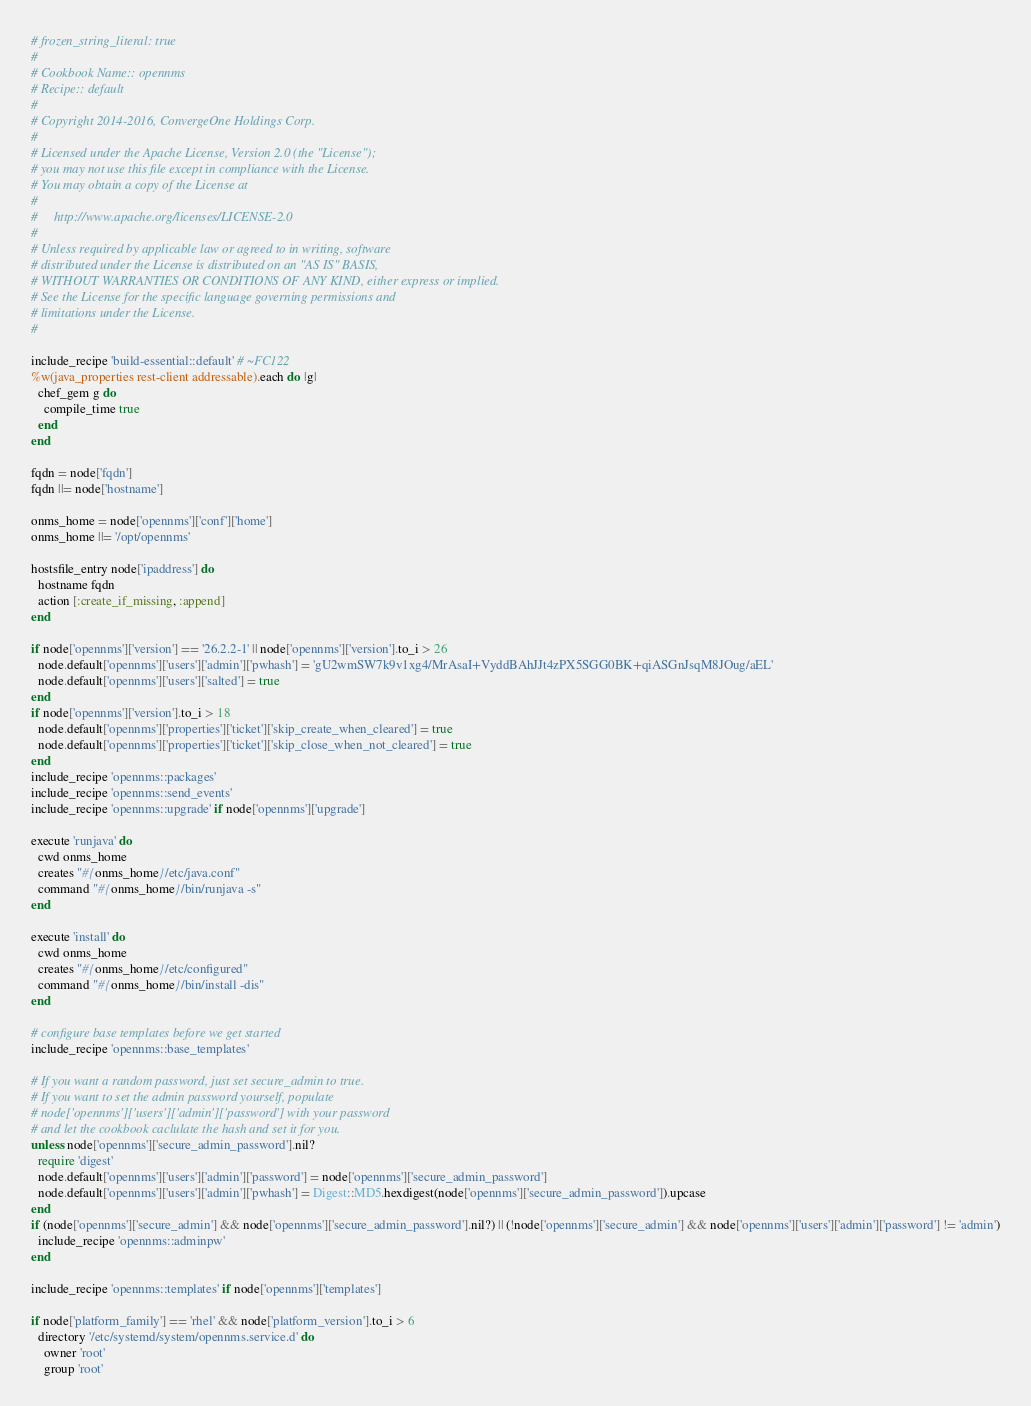<code> <loc_0><loc_0><loc_500><loc_500><_Ruby_># frozen_string_literal: true
#
# Cookbook Name:: opennms
# Recipe:: default
#
# Copyright 2014-2016, ConvergeOne Holdings Corp.
#
# Licensed under the Apache License, Version 2.0 (the "License");
# you may not use this file except in compliance with the License.
# You may obtain a copy of the License at
#
#     http://www.apache.org/licenses/LICENSE-2.0
#
# Unless required by applicable law or agreed to in writing, software
# distributed under the License is distributed on an "AS IS" BASIS,
# WITHOUT WARRANTIES OR CONDITIONS OF ANY KIND, either express or implied.
# See the License for the specific language governing permissions and
# limitations under the License.
#

include_recipe 'build-essential::default' # ~FC122
%w(java_properties rest-client addressable).each do |g|
  chef_gem g do
    compile_time true
  end
end

fqdn = node['fqdn']
fqdn ||= node['hostname']

onms_home = node['opennms']['conf']['home']
onms_home ||= '/opt/opennms'

hostsfile_entry node['ipaddress'] do
  hostname fqdn
  action [:create_if_missing, :append]
end

if node['opennms']['version'] == '26.2.2-1' || node['opennms']['version'].to_i > 26
  node.default['opennms']['users']['admin']['pwhash'] = 'gU2wmSW7k9v1xg4/MrAsaI+VyddBAhJJt4zPX5SGG0BK+qiASGnJsqM8JOug/aEL'
  node.default['opennms']['users']['salted'] = true
end
if node['opennms']['version'].to_i > 18
  node.default['opennms']['properties']['ticket']['skip_create_when_cleared'] = true
  node.default['opennms']['properties']['ticket']['skip_close_when_not_cleared'] = true
end
include_recipe 'opennms::packages'
include_recipe 'opennms::send_events'
include_recipe 'opennms::upgrade' if node['opennms']['upgrade']

execute 'runjava' do
  cwd onms_home
  creates "#{onms_home}/etc/java.conf"
  command "#{onms_home}/bin/runjava -s"
end

execute 'install' do
  cwd onms_home
  creates "#{onms_home}/etc/configured"
  command "#{onms_home}/bin/install -dis"
end

# configure base templates before we get started
include_recipe 'opennms::base_templates'

# If you want a random password, just set secure_admin to true.
# If you want to set the admin password yourself, populate
# node['opennms']['users']['admin']['password'] with your password
# and let the cookbook caclulate the hash and set it for you.
unless node['opennms']['secure_admin_password'].nil?
  require 'digest'
  node.default['opennms']['users']['admin']['password'] = node['opennms']['secure_admin_password']
  node.default['opennms']['users']['admin']['pwhash'] = Digest::MD5.hexdigest(node['opennms']['secure_admin_password']).upcase
end
if (node['opennms']['secure_admin'] && node['opennms']['secure_admin_password'].nil?) || (!node['opennms']['secure_admin'] && node['opennms']['users']['admin']['password'] != 'admin')
  include_recipe 'opennms::adminpw'
end

include_recipe 'opennms::templates' if node['opennms']['templates']

if node['platform_family'] == 'rhel' && node['platform_version'].to_i > 6
  directory '/etc/systemd/system/opennms.service.d' do
    owner 'root'
    group 'root'</code> 